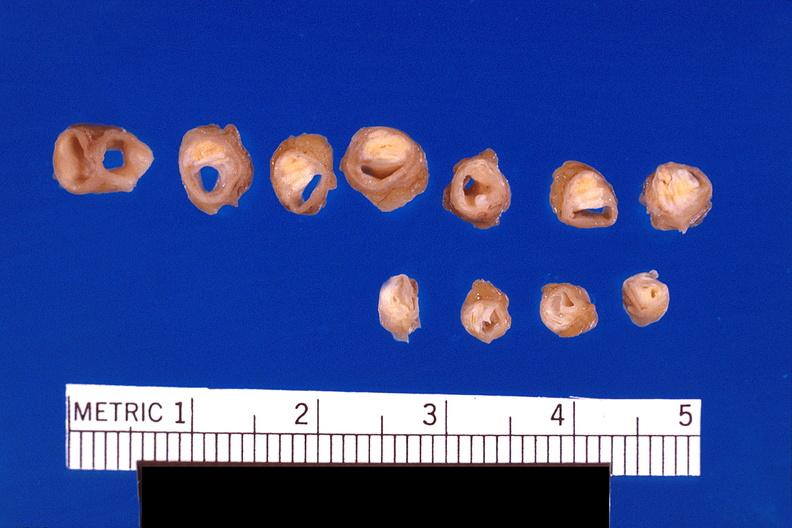what is present?
Answer the question using a single word or phrase. Vasculature 